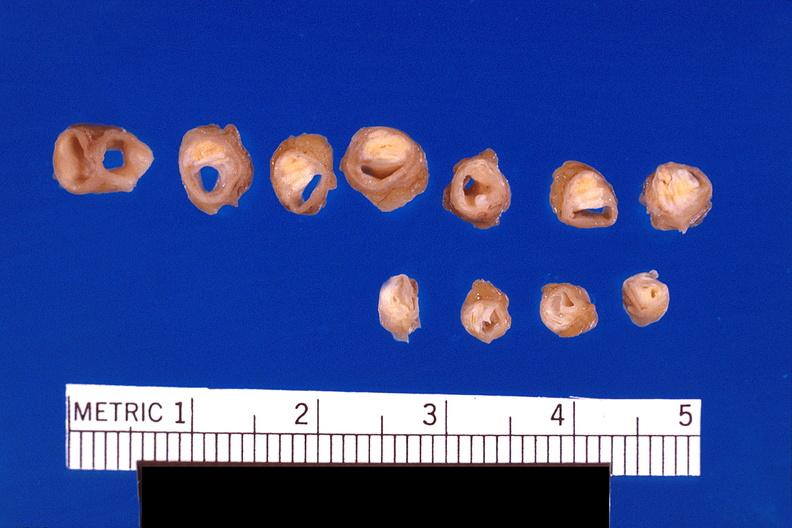what is present?
Answer the question using a single word or phrase. Vasculature 